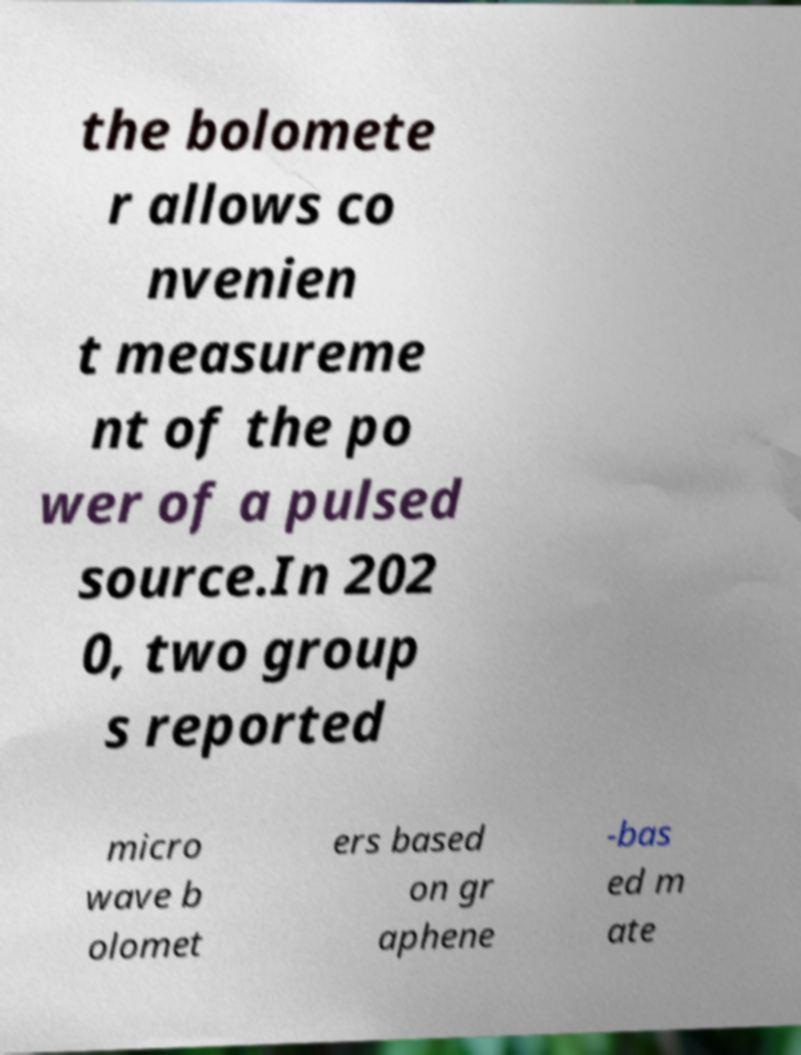Can you read and provide the text displayed in the image?This photo seems to have some interesting text. Can you extract and type it out for me? the bolomete r allows co nvenien t measureme nt of the po wer of a pulsed source.In 202 0, two group s reported micro wave b olomet ers based on gr aphene -bas ed m ate 